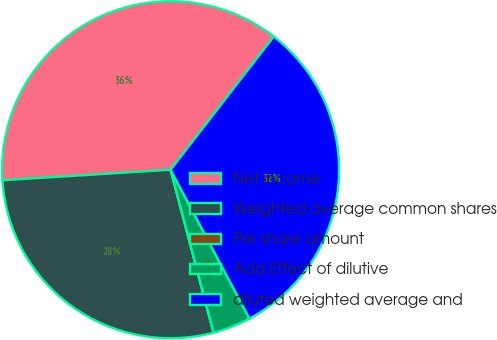<chart> <loc_0><loc_0><loc_500><loc_500><pie_chart><fcel>Net income<fcel>Weighted average common shares<fcel>Per share amount<fcel>Add Effect of dilutive<fcel>diluted weighted average and<nl><fcel>36.48%<fcel>28.11%<fcel>0.0%<fcel>3.65%<fcel>31.76%<nl></chart> 